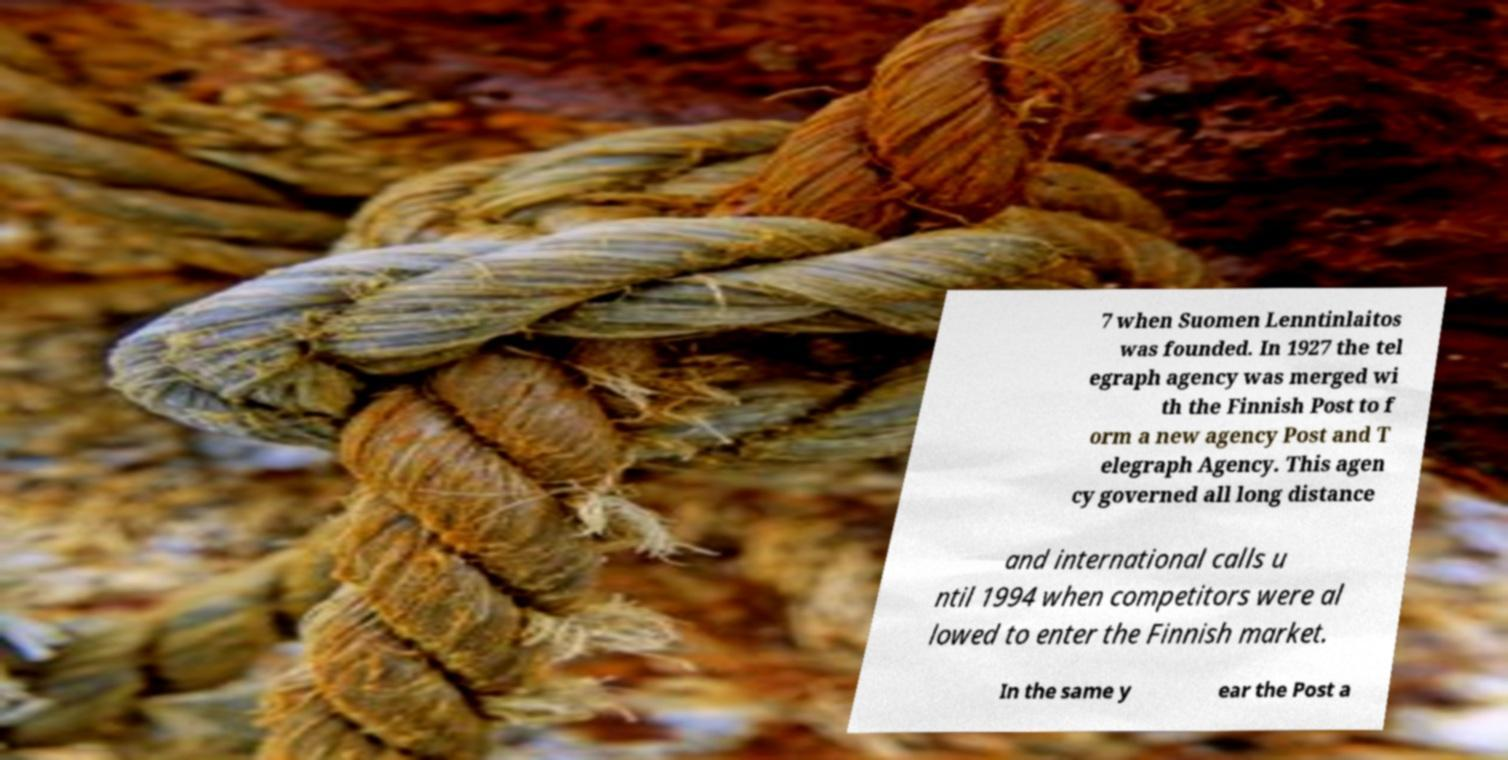Can you read and provide the text displayed in the image?This photo seems to have some interesting text. Can you extract and type it out for me? 7 when Suomen Lenntinlaitos was founded. In 1927 the tel egraph agency was merged wi th the Finnish Post to f orm a new agency Post and T elegraph Agency. This agen cy governed all long distance and international calls u ntil 1994 when competitors were al lowed to enter the Finnish market. In the same y ear the Post a 